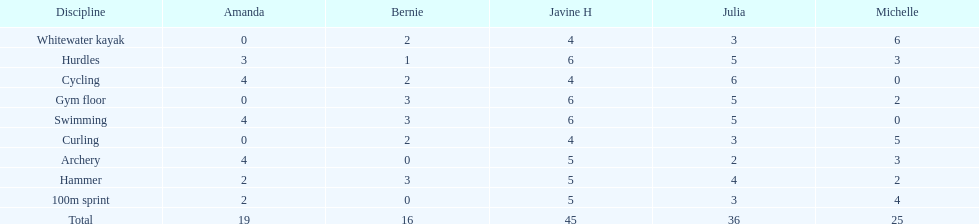Write the full table. {'header': ['Discipline', 'Amanda', 'Bernie', 'Javine H', 'Julia', 'Michelle'], 'rows': [['Whitewater kayak', '0', '2', '4', '3', '6'], ['Hurdles', '3', '1', '6', '5', '3'], ['Cycling', '4', '2', '4', '6', '0'], ['Gym floor', '0', '3', '6', '5', '2'], ['Swimming', '4', '3', '6', '5', '0'], ['Curling', '0', '2', '4', '3', '5'], ['Archery', '4', '0', '5', '2', '3'], ['Hammer', '2', '3', '5', '4', '2'], ['100m sprint', '2', '0', '5', '3', '4'], ['Total', '19', '16', '45', '36', '25']]} Which of the girls had the least amount in archery? Bernie. 